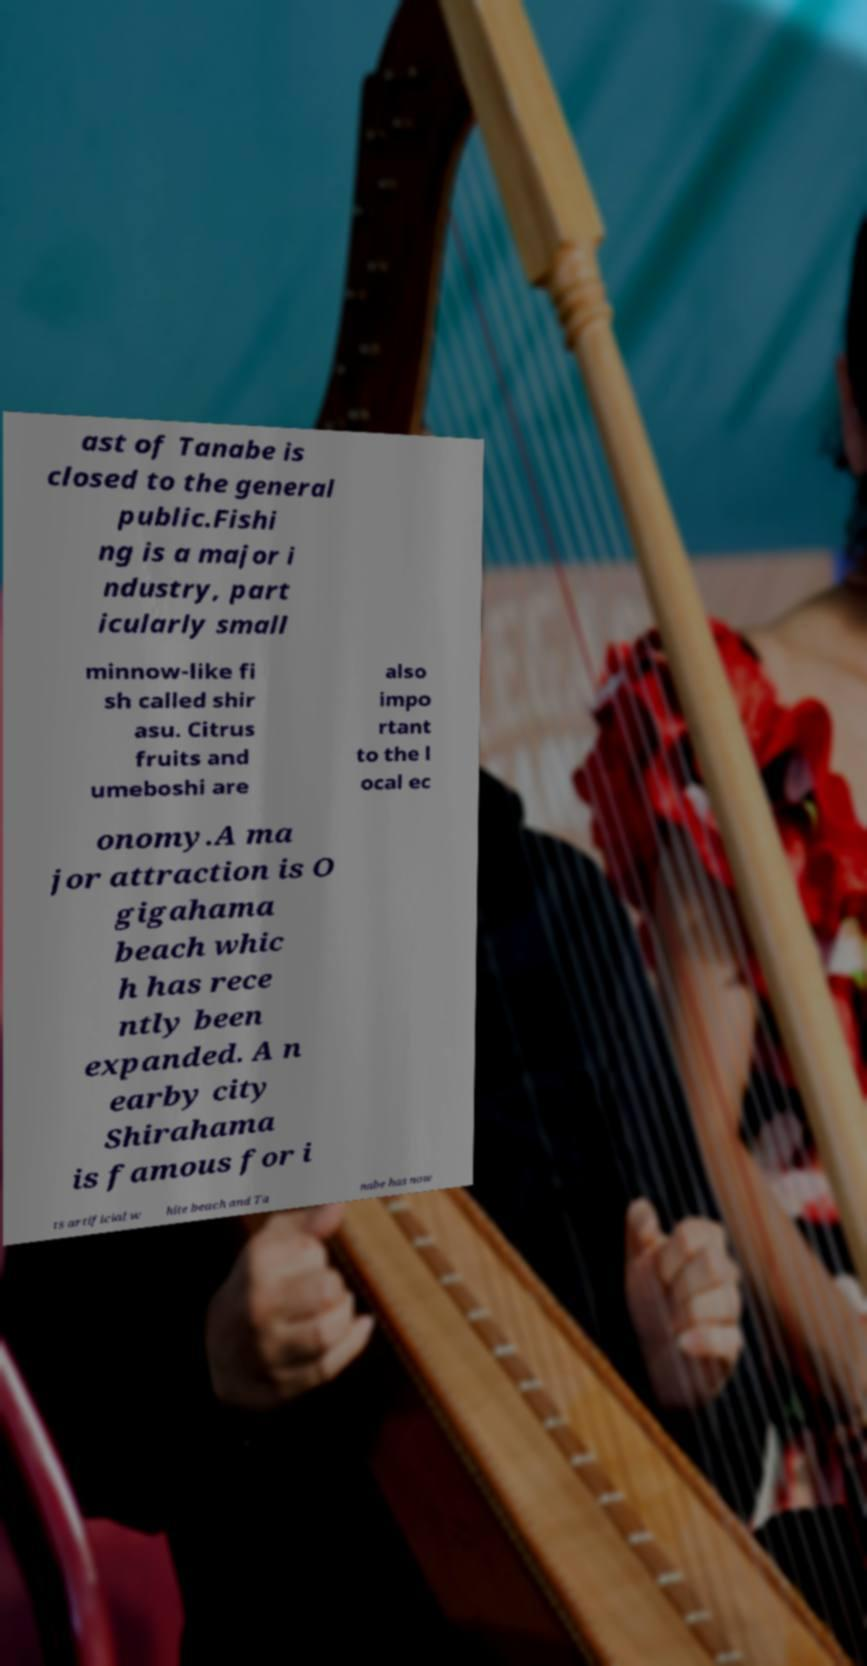Can you read and provide the text displayed in the image?This photo seems to have some interesting text. Can you extract and type it out for me? ast of Tanabe is closed to the general public.Fishi ng is a major i ndustry, part icularly small minnow-like fi sh called shir asu. Citrus fruits and umeboshi are also impo rtant to the l ocal ec onomy.A ma jor attraction is O gigahama beach whic h has rece ntly been expanded. A n earby city Shirahama is famous for i ts artificial w hite beach and Ta nabe has now 